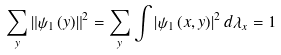<formula> <loc_0><loc_0><loc_500><loc_500>\sum _ { y } \left \| \psi _ { 1 } \left ( y \right ) \right \| ^ { 2 } = \sum _ { y } \int \left | \psi _ { 1 } \left ( x , y \right ) \right | ^ { 2 } d \lambda _ { x } = 1</formula> 